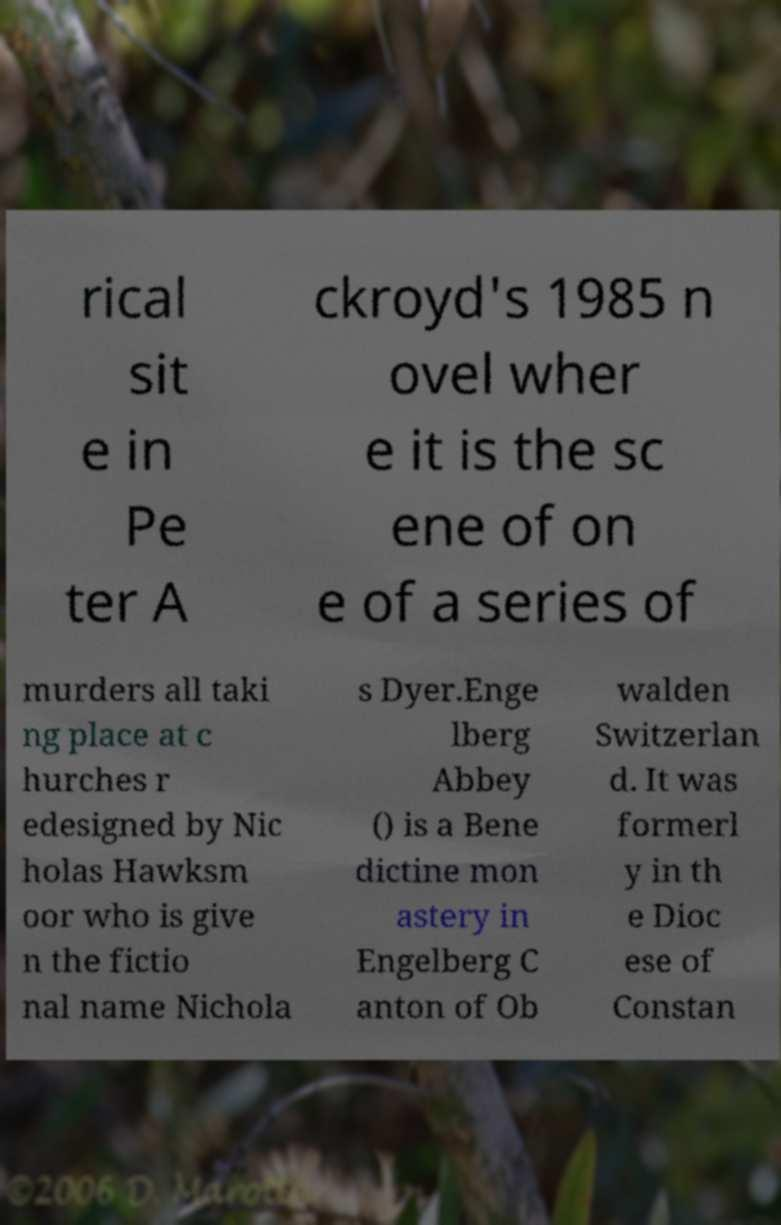Can you read and provide the text displayed in the image?This photo seems to have some interesting text. Can you extract and type it out for me? rical sit e in Pe ter A ckroyd's 1985 n ovel wher e it is the sc ene of on e of a series of murders all taki ng place at c hurches r edesigned by Nic holas Hawksm oor who is give n the fictio nal name Nichola s Dyer.Enge lberg Abbey () is a Bene dictine mon astery in Engelberg C anton of Ob walden Switzerlan d. It was formerl y in th e Dioc ese of Constan 